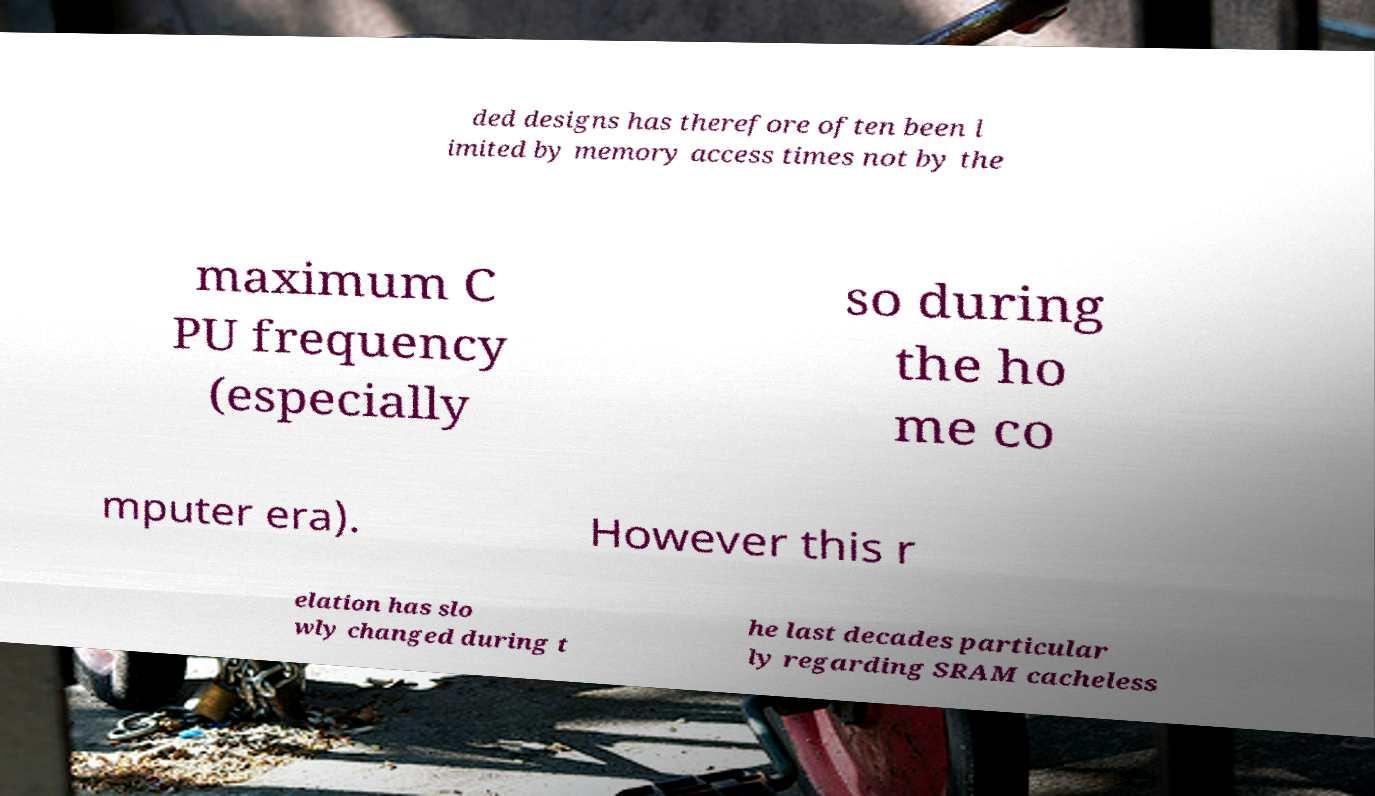Could you extract and type out the text from this image? ded designs has therefore often been l imited by memory access times not by the maximum C PU frequency (especially so during the ho me co mputer era). However this r elation has slo wly changed during t he last decades particular ly regarding SRAM cacheless 